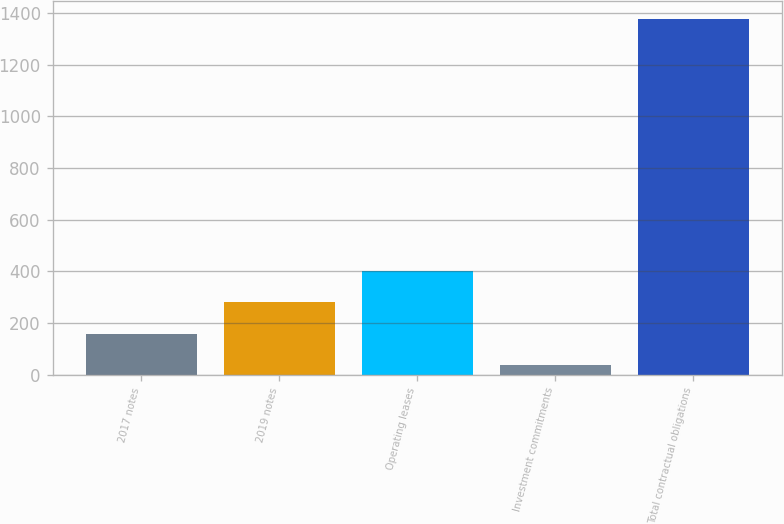Convert chart. <chart><loc_0><loc_0><loc_500><loc_500><bar_chart><fcel>2017 notes<fcel>2019 notes<fcel>Operating leases<fcel>Investment commitments<fcel>Total contractual obligations<nl><fcel>158.9<fcel>280.8<fcel>402.7<fcel>37<fcel>1377.9<nl></chart> 